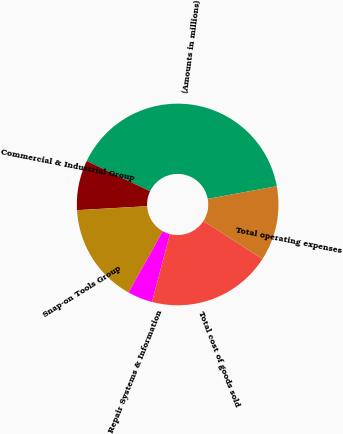Convert chart to OTSL. <chart><loc_0><loc_0><loc_500><loc_500><pie_chart><fcel>(Amounts in millions)<fcel>Commercial & Industrial Group<fcel>Snap-on Tools Group<fcel>Repair Systems & Information<fcel>Total cost of goods sold<fcel>Total operating expenses<nl><fcel>39.99%<fcel>8.0%<fcel>16.0%<fcel>4.0%<fcel>20.0%<fcel>12.0%<nl></chart> 